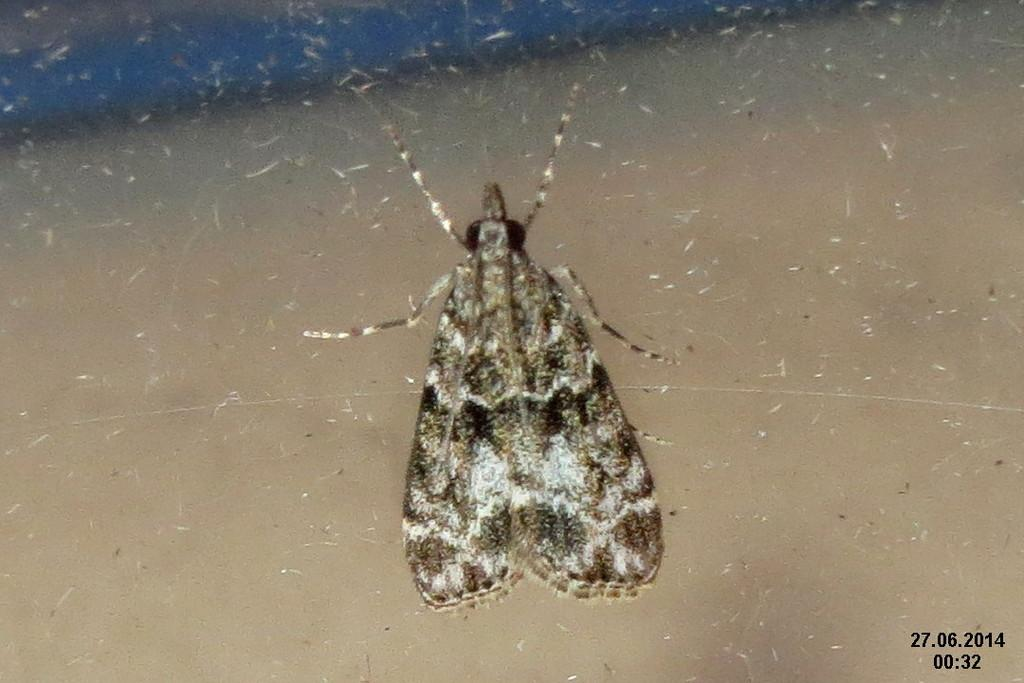What is the main subject in the center of the image? There is a fly in the center of the image. What else can be seen in the image besides the fly? There is text visible in the background of the image. What type of handcuffs are being used on the fly in the image? There are no handcuffs or police-related elements present in the image; it features a fly and text in the background. 